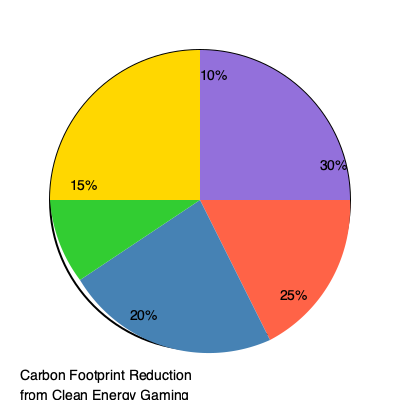Based on the pie chart showing the carbon footprint reduction from using clean energy for gaming consoles, what percentage of the total reduction comes from the two largest contributing factors combined? To solve this problem, we need to follow these steps:

1. Identify the two largest contributing factors in the pie chart.
2. Add their respective percentages together.

Looking at the pie chart:
1. The largest slice represents 30% of the total reduction.
2. The second-largest slice represents 25% of the total reduction.

To calculate the combined percentage:
$$ 30\% + 25\% = 55\% $$

Therefore, the two largest contributing factors account for 55% of the total carbon footprint reduction from using clean energy for gaming consoles.
Answer: 55% 